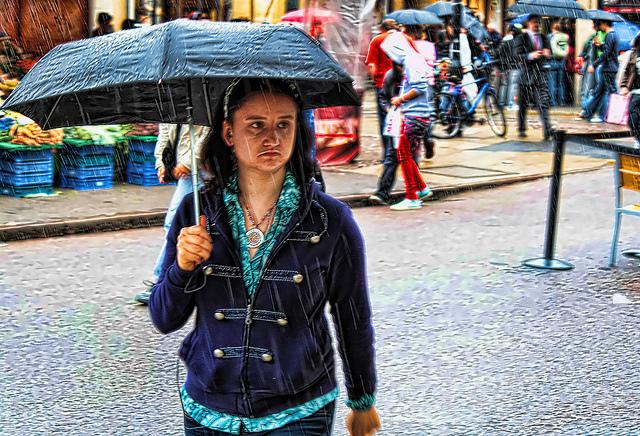What indicates that it just recently started raining in the photograph?
Write a very short answer. Umbrella. What color is the umbrella?
Give a very brief answer. Black. Is it raining?
Be succinct. Yes. 